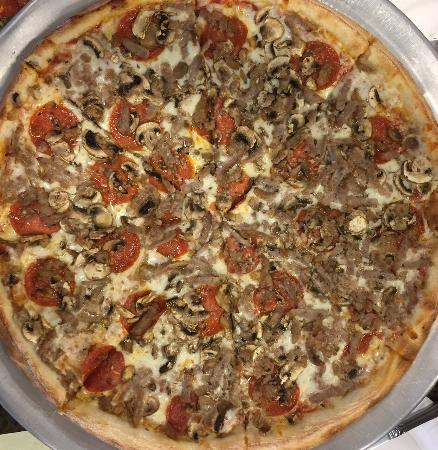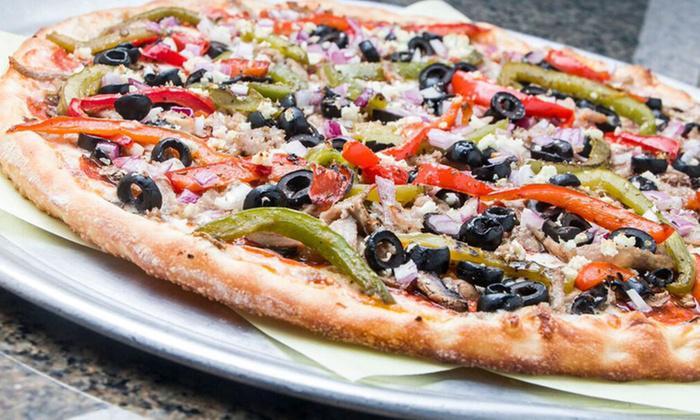The first image is the image on the left, the second image is the image on the right. Analyze the images presented: Is the assertion "One image shows a whole pizza with black olives and red pepper strips on top, and the other image shows no more than two wedge-shaped slices on something made of paper." valid? Answer yes or no. No. The first image is the image on the left, the second image is the image on the right. Assess this claim about the two images: "There are two whole pizzas ready to eat.". Correct or not? Answer yes or no. Yes. 